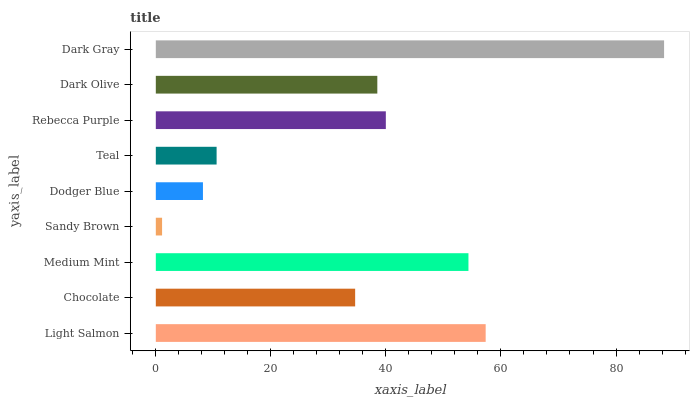Is Sandy Brown the minimum?
Answer yes or no. Yes. Is Dark Gray the maximum?
Answer yes or no. Yes. Is Chocolate the minimum?
Answer yes or no. No. Is Chocolate the maximum?
Answer yes or no. No. Is Light Salmon greater than Chocolate?
Answer yes or no. Yes. Is Chocolate less than Light Salmon?
Answer yes or no. Yes. Is Chocolate greater than Light Salmon?
Answer yes or no. No. Is Light Salmon less than Chocolate?
Answer yes or no. No. Is Dark Olive the high median?
Answer yes or no. Yes. Is Dark Olive the low median?
Answer yes or no. Yes. Is Sandy Brown the high median?
Answer yes or no. No. Is Light Salmon the low median?
Answer yes or no. No. 